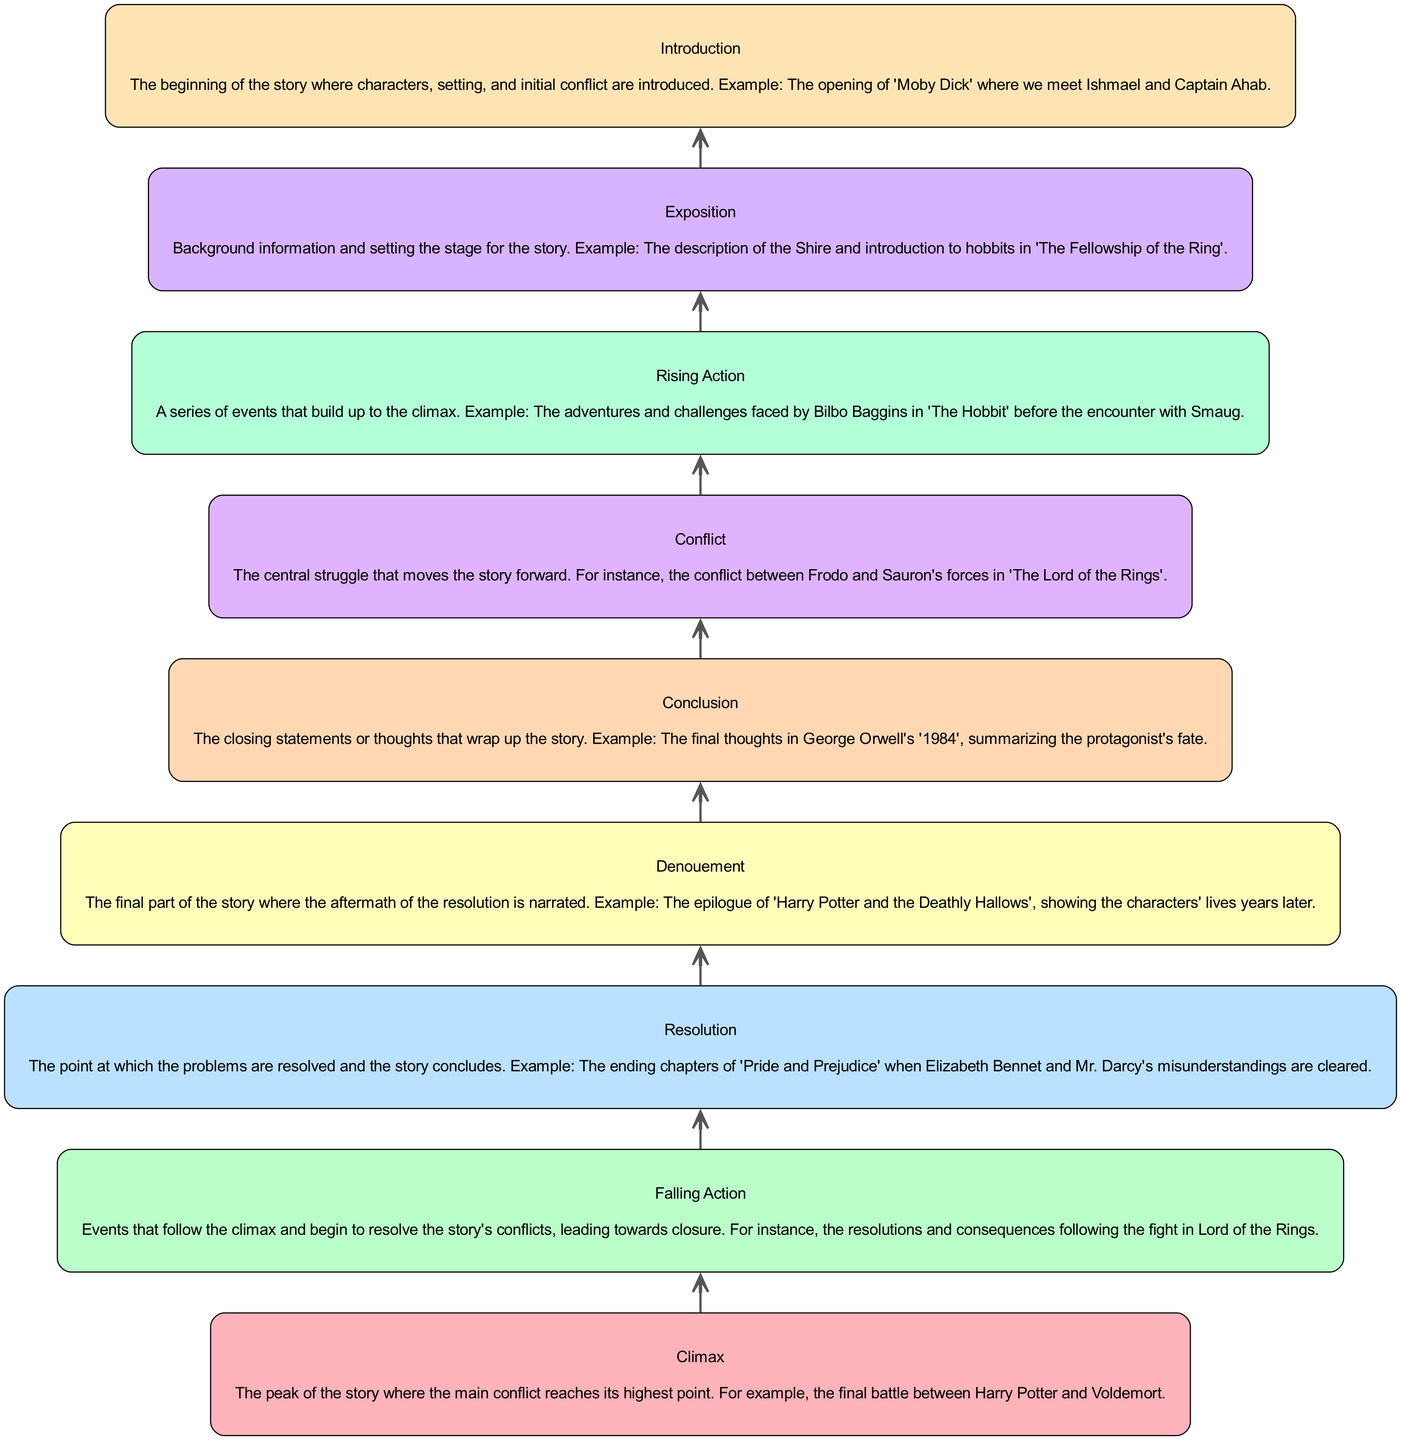What is the first element in the flowchart? The flowchart begins with the first element named "Introduction." This can be identified by looking at the bottom of the diagram, where the elements are arranged in order of development from bottom to top.
Answer: Introduction How many main elements are shown in the flowchart? To determine the number of main elements, we can count each unique element provided in the data. In total, there are nine distinct elements listed in the "Introduction to Climax Development Flowchart."
Answer: Nine What element follows "Conflict" in the flowchart? By examining the flow of the diagram, we can identify the element that directly follows "Conflict." The flow indicates that the next element up from "Conflict" is "Rising Action."
Answer: Rising Action What is the peak of the story referred to in the diagram? The diagram prominently features "Climax" as the element representing the peak of the story. It is located near the top of the flowchart, indicating that it is a significant point in the narrative structure.
Answer: Climax Which element describes the closing thoughts of the story? In the flowchart, the element that captures the closing thoughts or final statements of the story is labeled "Conclusion." This is the last element at the very top of the diagram.
Answer: Conclusion How does "Rising Action" relate to "Exposition" in the flowchart? "Rising Action" comes directly after "Exposition" according to the flow in the diagram. This shows a narrative structure where the background information leads to subsequent events that build tension.
Answer: Rising Action follows Exposition What is the relationship between "Falling Action" and "Climax"? The diagram illustrates that "Falling Action" occurs right after "Climax," showing that it consists of events that resolve the conflict following the peak of the story. This relationship denotes a direct sequential flow in the narrative structure.
Answer: Falling Action follows Climax What element marks the final part of the story? In the diagram, the final part of the story is represented by the "Denouement." This is located above "Resolution" and signifies the aftermath after the main conflicts are resolved.
Answer: Denouement What is the main function of "Exposition" in the flowchart? The "Exposition" serves as the initial setup phase of the story, providing crucial background information and introducing characters and settings. This foundational role is essential for understanding the subsequent narrative developments.
Answer: Background information 